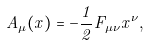Convert formula to latex. <formula><loc_0><loc_0><loc_500><loc_500>A _ { \mu } ( x ) = - { \frac { 1 } { 2 } } F _ { \mu \nu } x ^ { \nu } ,</formula> 